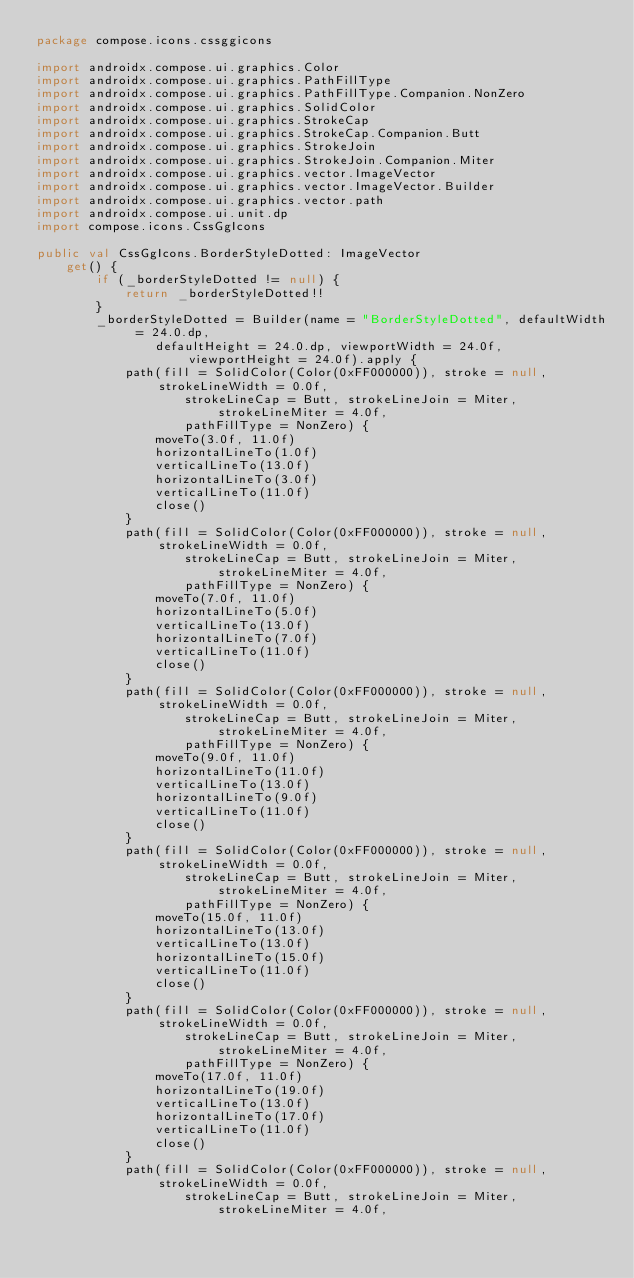Convert code to text. <code><loc_0><loc_0><loc_500><loc_500><_Kotlin_>package compose.icons.cssggicons

import androidx.compose.ui.graphics.Color
import androidx.compose.ui.graphics.PathFillType
import androidx.compose.ui.graphics.PathFillType.Companion.NonZero
import androidx.compose.ui.graphics.SolidColor
import androidx.compose.ui.graphics.StrokeCap
import androidx.compose.ui.graphics.StrokeCap.Companion.Butt
import androidx.compose.ui.graphics.StrokeJoin
import androidx.compose.ui.graphics.StrokeJoin.Companion.Miter
import androidx.compose.ui.graphics.vector.ImageVector
import androidx.compose.ui.graphics.vector.ImageVector.Builder
import androidx.compose.ui.graphics.vector.path
import androidx.compose.ui.unit.dp
import compose.icons.CssGgIcons

public val CssGgIcons.BorderStyleDotted: ImageVector
    get() {
        if (_borderStyleDotted != null) {
            return _borderStyleDotted!!
        }
        _borderStyleDotted = Builder(name = "BorderStyleDotted", defaultWidth = 24.0.dp,
                defaultHeight = 24.0.dp, viewportWidth = 24.0f, viewportHeight = 24.0f).apply {
            path(fill = SolidColor(Color(0xFF000000)), stroke = null, strokeLineWidth = 0.0f,
                    strokeLineCap = Butt, strokeLineJoin = Miter, strokeLineMiter = 4.0f,
                    pathFillType = NonZero) {
                moveTo(3.0f, 11.0f)
                horizontalLineTo(1.0f)
                verticalLineTo(13.0f)
                horizontalLineTo(3.0f)
                verticalLineTo(11.0f)
                close()
            }
            path(fill = SolidColor(Color(0xFF000000)), stroke = null, strokeLineWidth = 0.0f,
                    strokeLineCap = Butt, strokeLineJoin = Miter, strokeLineMiter = 4.0f,
                    pathFillType = NonZero) {
                moveTo(7.0f, 11.0f)
                horizontalLineTo(5.0f)
                verticalLineTo(13.0f)
                horizontalLineTo(7.0f)
                verticalLineTo(11.0f)
                close()
            }
            path(fill = SolidColor(Color(0xFF000000)), stroke = null, strokeLineWidth = 0.0f,
                    strokeLineCap = Butt, strokeLineJoin = Miter, strokeLineMiter = 4.0f,
                    pathFillType = NonZero) {
                moveTo(9.0f, 11.0f)
                horizontalLineTo(11.0f)
                verticalLineTo(13.0f)
                horizontalLineTo(9.0f)
                verticalLineTo(11.0f)
                close()
            }
            path(fill = SolidColor(Color(0xFF000000)), stroke = null, strokeLineWidth = 0.0f,
                    strokeLineCap = Butt, strokeLineJoin = Miter, strokeLineMiter = 4.0f,
                    pathFillType = NonZero) {
                moveTo(15.0f, 11.0f)
                horizontalLineTo(13.0f)
                verticalLineTo(13.0f)
                horizontalLineTo(15.0f)
                verticalLineTo(11.0f)
                close()
            }
            path(fill = SolidColor(Color(0xFF000000)), stroke = null, strokeLineWidth = 0.0f,
                    strokeLineCap = Butt, strokeLineJoin = Miter, strokeLineMiter = 4.0f,
                    pathFillType = NonZero) {
                moveTo(17.0f, 11.0f)
                horizontalLineTo(19.0f)
                verticalLineTo(13.0f)
                horizontalLineTo(17.0f)
                verticalLineTo(11.0f)
                close()
            }
            path(fill = SolidColor(Color(0xFF000000)), stroke = null, strokeLineWidth = 0.0f,
                    strokeLineCap = Butt, strokeLineJoin = Miter, strokeLineMiter = 4.0f,</code> 